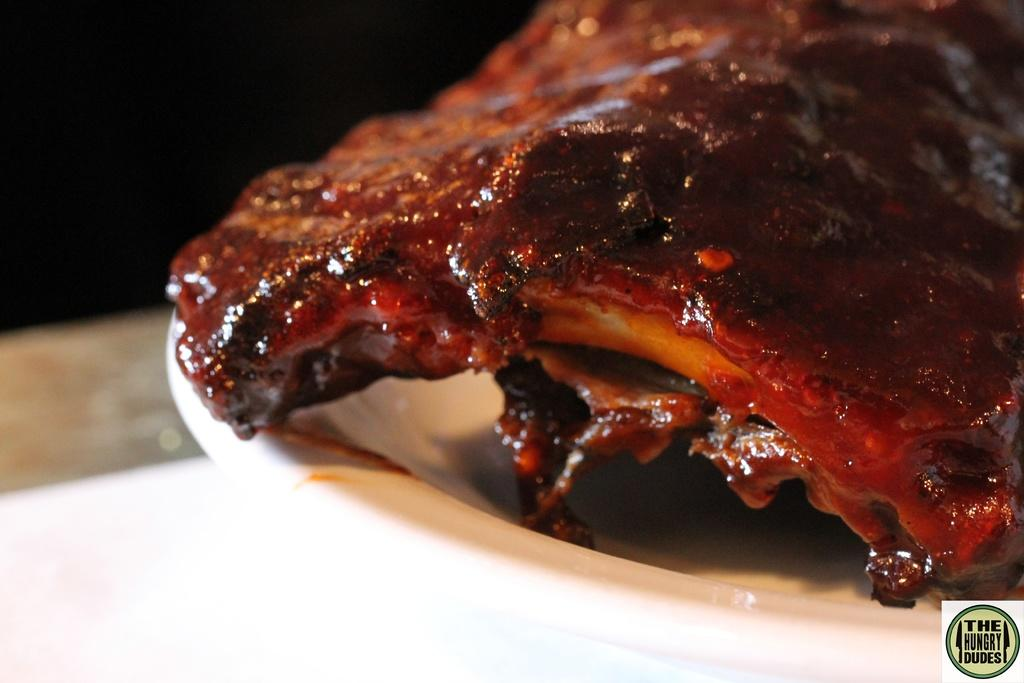What is on the plate that is visible in the image? There is food in a plate in the image. Where is the plate located in the image? The plate is placed on a surface in the image. How many giraffes can be seen in the image? There are no giraffes present in the image. 